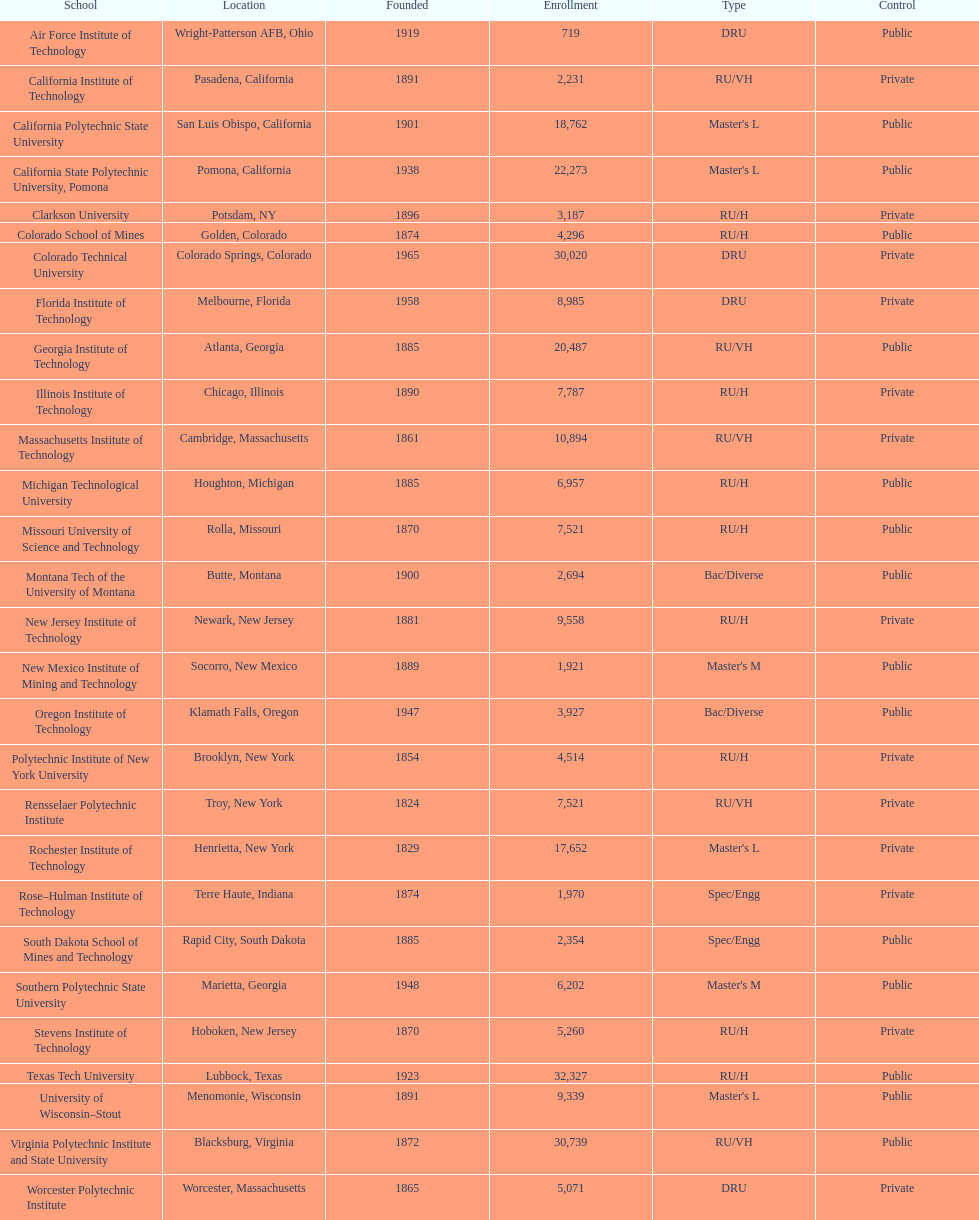What is the number of us technological schools in the state of california? 3. 